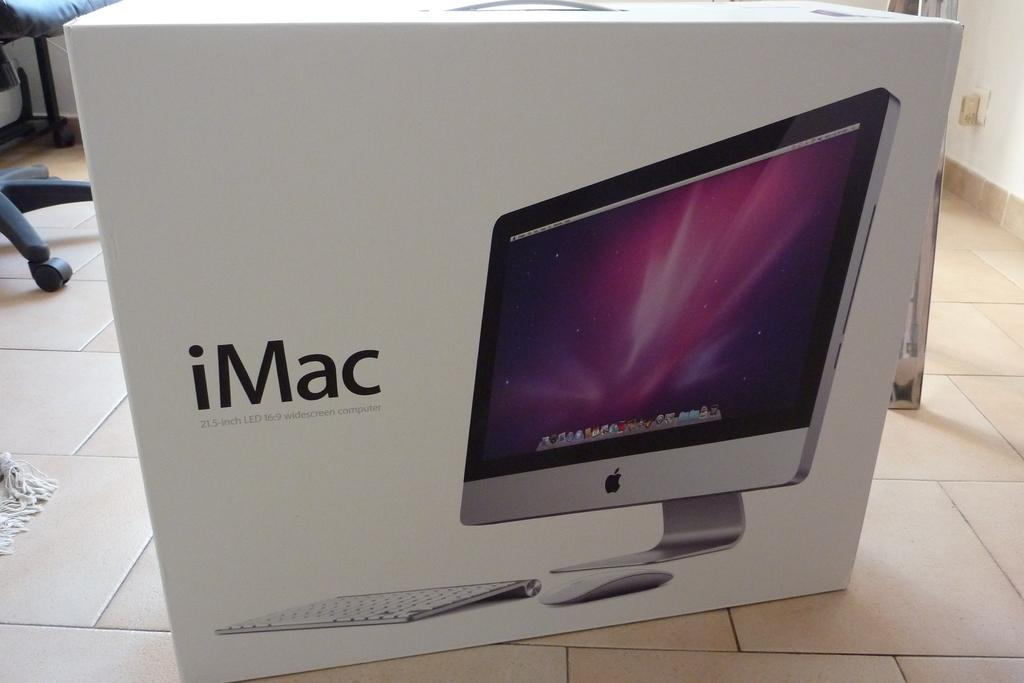<image>
Create a compact narrative representing the image presented. a box for an iMac monitor and keyboard is sitting on the floor 